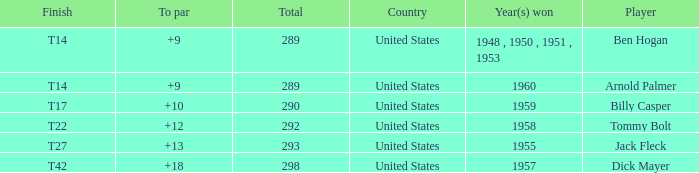What is the total number of Total, when To Par is 12? 1.0. Would you be able to parse every entry in this table? {'header': ['Finish', 'To par', 'Total', 'Country', 'Year(s) won', 'Player'], 'rows': [['T14', '+9', '289', 'United States', '1948 , 1950 , 1951 , 1953', 'Ben Hogan'], ['T14', '+9', '289', 'United States', '1960', 'Arnold Palmer'], ['T17', '+10', '290', 'United States', '1959', 'Billy Casper'], ['T22', '+12', '292', 'United States', '1958', 'Tommy Bolt'], ['T27', '+13', '293', 'United States', '1955', 'Jack Fleck'], ['T42', '+18', '298', 'United States', '1957', 'Dick Mayer']]} 